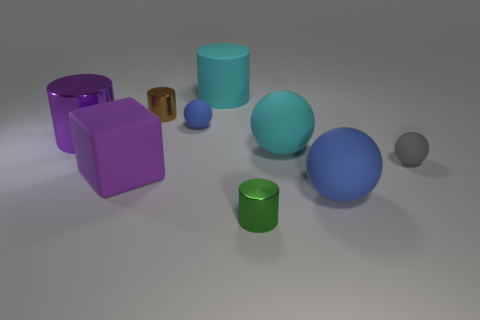Subtract 1 cylinders. How many cylinders are left? 3 Subtract all red cubes. Subtract all blue balls. How many cubes are left? 1 Subtract all balls. How many objects are left? 5 Subtract all rubber blocks. Subtract all large matte cubes. How many objects are left? 7 Add 6 brown cylinders. How many brown cylinders are left? 7 Add 7 large purple rubber objects. How many large purple rubber objects exist? 8 Subtract 0 brown spheres. How many objects are left? 9 